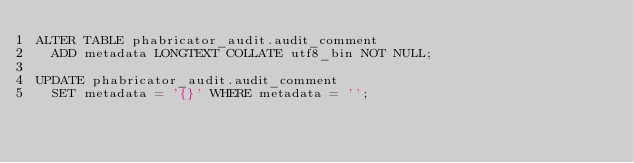Convert code to text. <code><loc_0><loc_0><loc_500><loc_500><_SQL_>ALTER TABLE phabricator_audit.audit_comment
  ADD metadata LONGTEXT COLLATE utf8_bin NOT NULL;

UPDATE phabricator_audit.audit_comment
  SET metadata = '{}' WHERE metadata = '';
</code> 